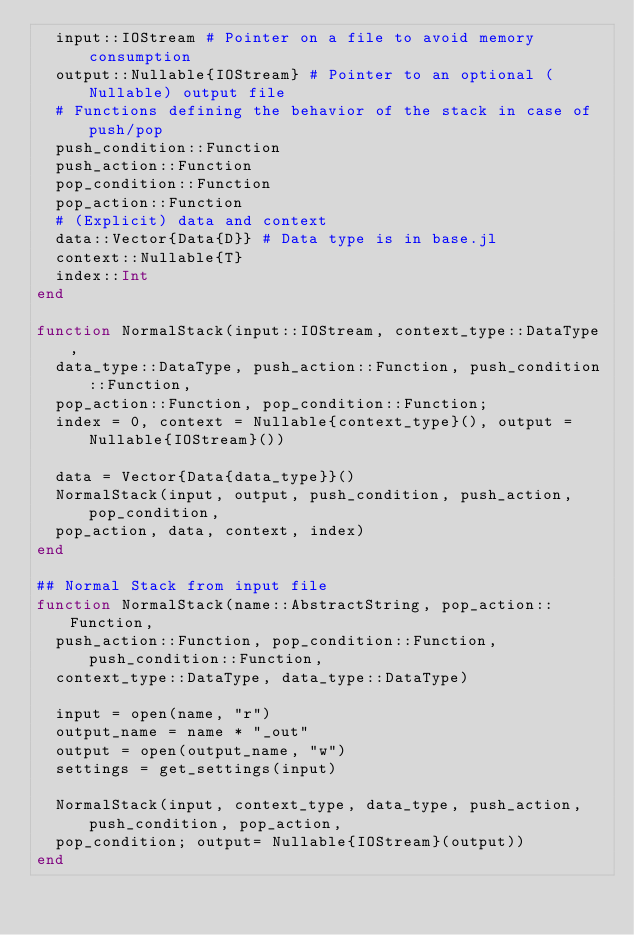<code> <loc_0><loc_0><loc_500><loc_500><_Julia_>  input::IOStream # Pointer on a file to avoid memory consumption
  output::Nullable{IOStream} # Pointer to an optional (Nullable) output file
  # Functions defining the behavior of the stack in case of push/pop
  push_condition::Function
  push_action::Function
  pop_condition::Function
  pop_action::Function
  # (Explicit) data and context
  data::Vector{Data{D}} # Data type is in base.jl
  context::Nullable{T}
  index::Int
end

function NormalStack(input::IOStream, context_type::DataType,
  data_type::DataType, push_action::Function, push_condition::Function,
  pop_action::Function, pop_condition::Function;
  index = 0, context = Nullable{context_type}(), output = Nullable{IOStream}())

  data = Vector{Data{data_type}}()
  NormalStack(input, output, push_condition, push_action, pop_condition,
  pop_action, data, context, index)
end

## Normal Stack from input file
function NormalStack(name::AbstractString, pop_action::Function,
  push_action::Function, pop_condition::Function, push_condition::Function,
  context_type::DataType, data_type::DataType)

  input = open(name, "r")
  output_name = name * "_out"
  output = open(output_name, "w")
  settings = get_settings(input)

  NormalStack(input, context_type, data_type, push_action, push_condition, pop_action,
  pop_condition; output= Nullable{IOStream}(output))
end
</code> 